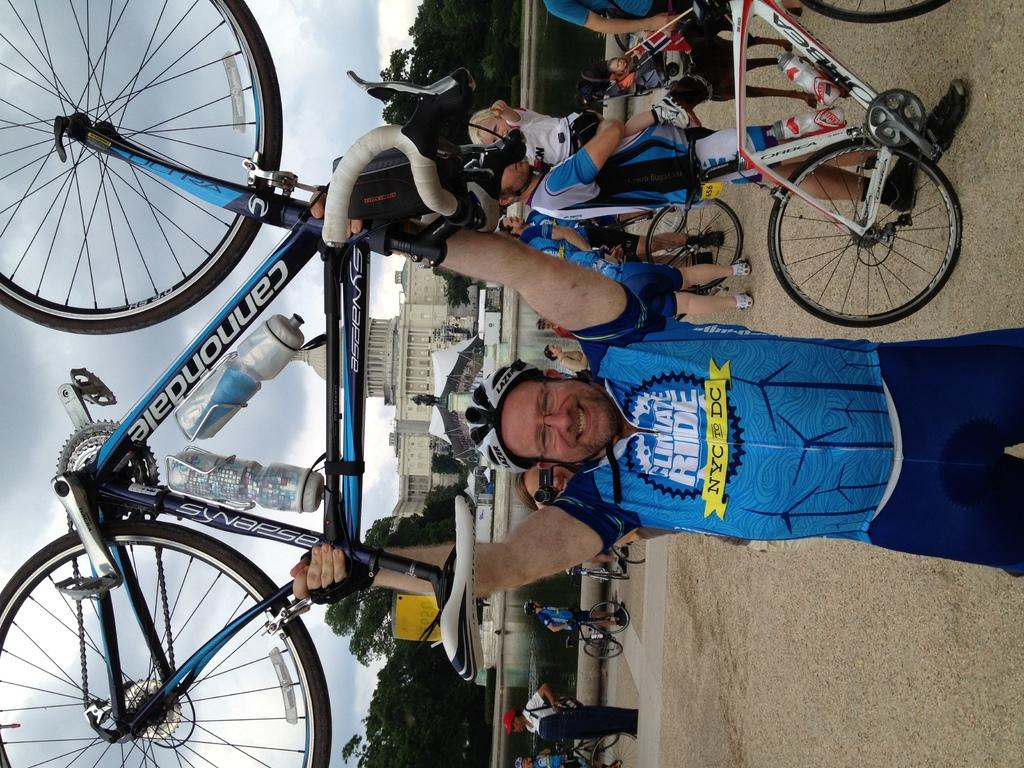Who or what can be seen in the image? There are people in the image. What are the people using in the image? There are bicycles in the image. What type of structures are visible in the image? There are buildings in the image. What type of vegetation is present in the image? There are trees in the image. What is visible in the background of the image? The sky is visible in the image, and clouds are present in the sky. What invention is being demonstrated by the people in the image? There is no specific invention being demonstrated by the people in the image; they are simply riding bicycles. What type of paper is being used by the people in the image? There is no paper present in the image. 